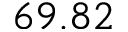<formula> <loc_0><loc_0><loc_500><loc_500>6 9 . 8 2</formula> 